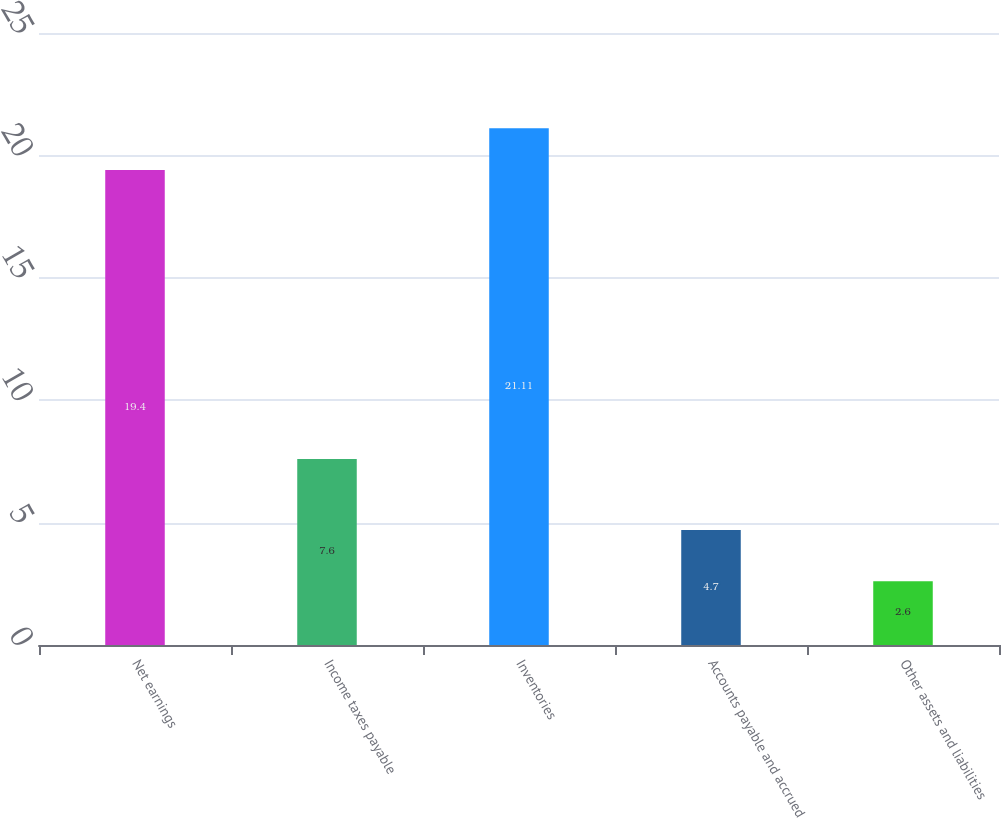Convert chart to OTSL. <chart><loc_0><loc_0><loc_500><loc_500><bar_chart><fcel>Net earnings<fcel>Income taxes payable<fcel>Inventories<fcel>Accounts payable and accrued<fcel>Other assets and liabilities<nl><fcel>19.4<fcel>7.6<fcel>21.11<fcel>4.7<fcel>2.6<nl></chart> 